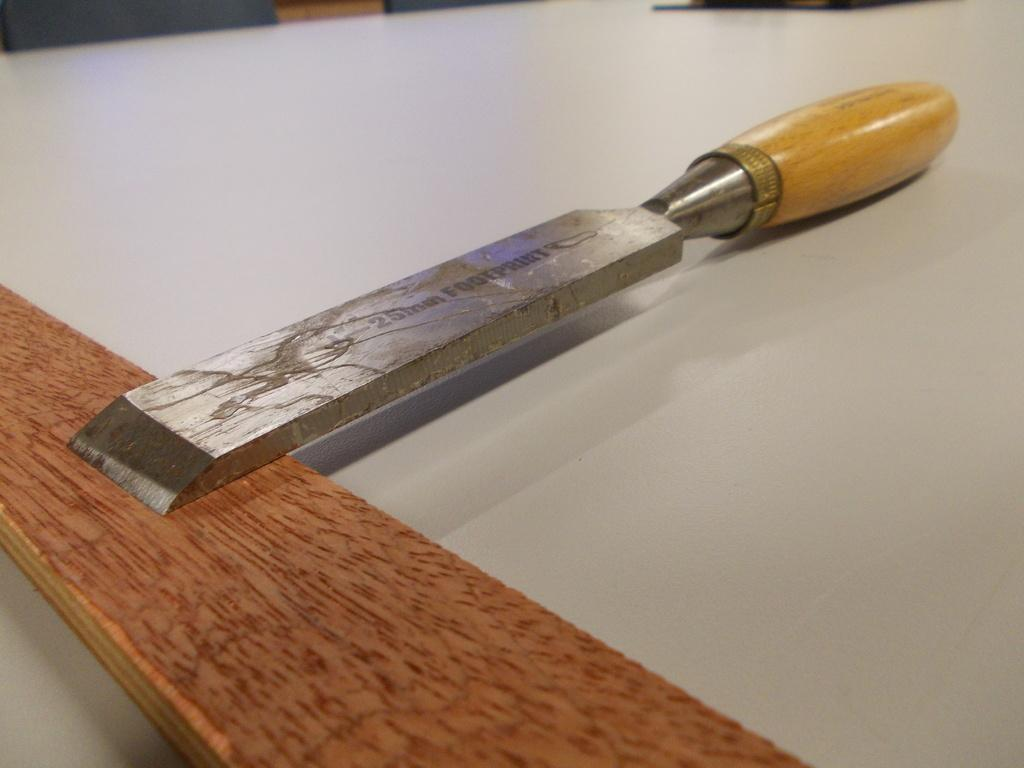What object can be seen in the image? There is a tool in the image. What is the color of the surface on which the tool is placed? The tool is on a white color surface. How many grapes are present in the image? There are no grapes present in the image. What type of ray is visible in the image? There is no ray visible in the image. 